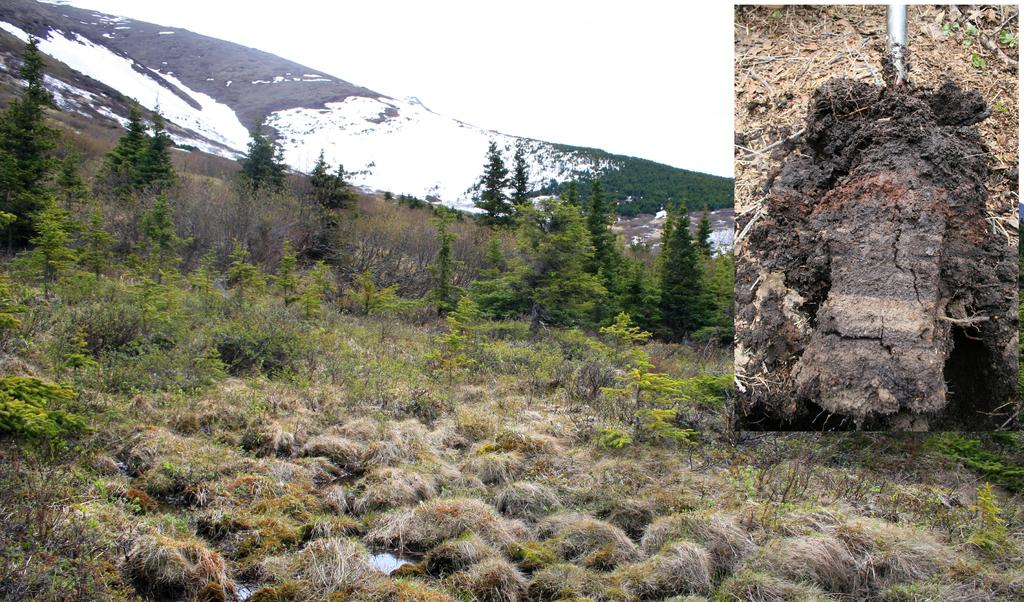What type of artwork is depicted in the image? The image appears to be a collage. What type of natural material can be seen in the image? There is dried grass in the image. What type of vegetation is present in the image? There are trees and plants in the image. What type of landscape feature might be present in the image? There is a snowy mountain in the image, although this is uncertain. What type of terrain is depicted in the image? There is mud in the image. What type of ink is used to write on the jeans in the image? There are no jeans or writing present in the image; it is a collage featuring dried grass, trees, plants, and possibly a snowy mountain. 